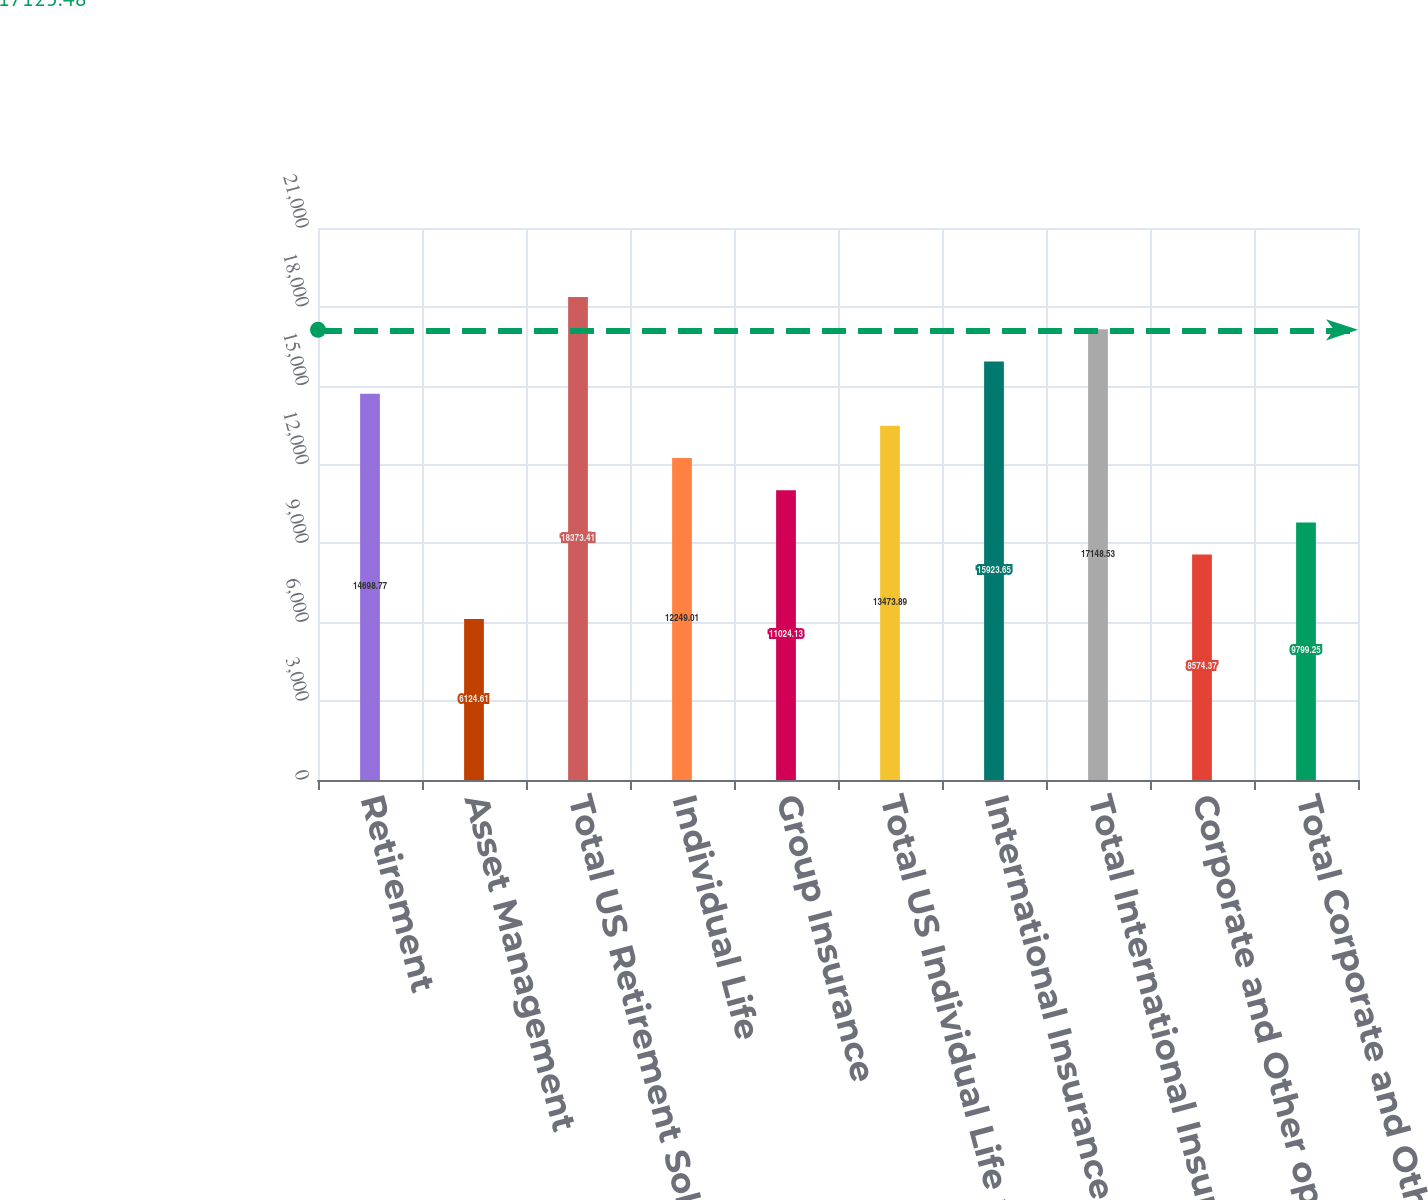Convert chart to OTSL. <chart><loc_0><loc_0><loc_500><loc_500><bar_chart><fcel>Retirement<fcel>Asset Management<fcel>Total US Retirement Solutions<fcel>Individual Life<fcel>Group Insurance<fcel>Total US Individual Life and<fcel>International Insurance<fcel>Total International Insurance<fcel>Corporate and Other operations<fcel>Total Corporate and Other<nl><fcel>14698.8<fcel>6124.61<fcel>18373.4<fcel>12249<fcel>11024.1<fcel>13473.9<fcel>15923.6<fcel>17148.5<fcel>8574.37<fcel>9799.25<nl></chart> 